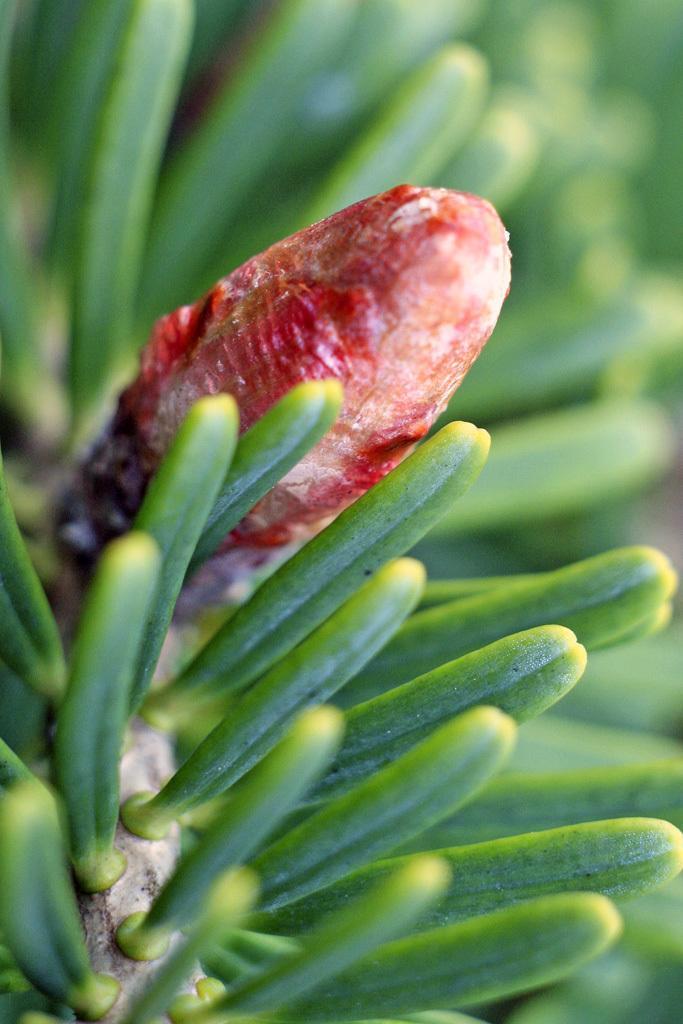How would you summarize this image in a sentence or two? In this image, there is a branch contains some leaves and bud. 